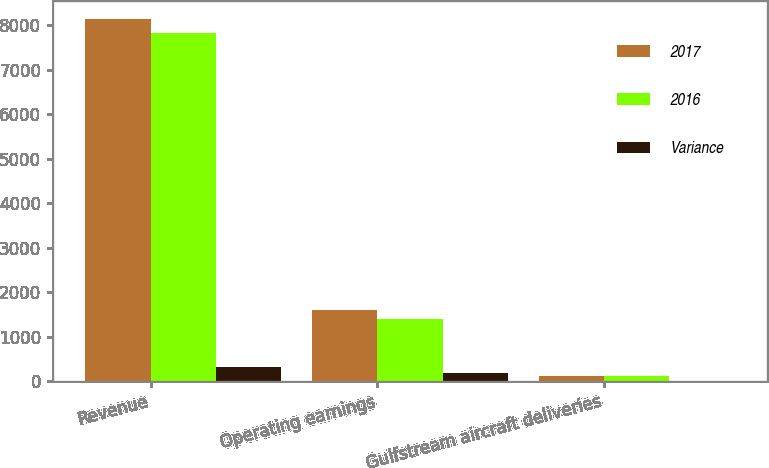Convert chart to OTSL. <chart><loc_0><loc_0><loc_500><loc_500><stacked_bar_chart><ecel><fcel>Revenue<fcel>Operating earnings<fcel>Gulfstream aircraft deliveries<nl><fcel>2017<fcel>8129<fcel>1593<fcel>120<nl><fcel>2016<fcel>7815<fcel>1407<fcel>121<nl><fcel>Variance<fcel>314<fcel>186<fcel>1<nl></chart> 